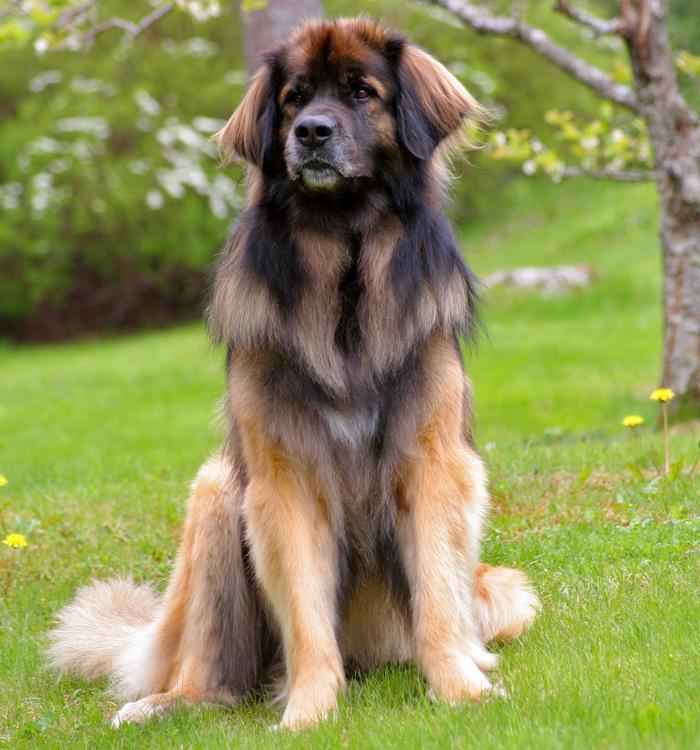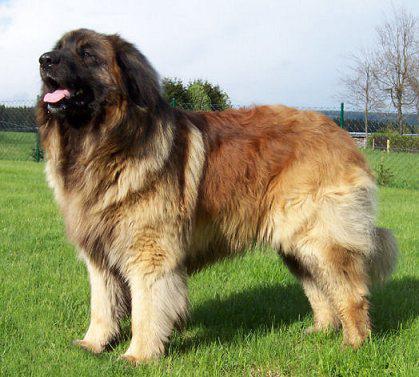The first image is the image on the left, the second image is the image on the right. For the images shown, is this caption "No image contains a grassy ground, and at least one image contains a dog standing upright on snow." true? Answer yes or no. No. The first image is the image on the left, the second image is the image on the right. Assess this claim about the two images: "One of the images shows a single dog standing in snow.". Correct or not? Answer yes or no. No. 